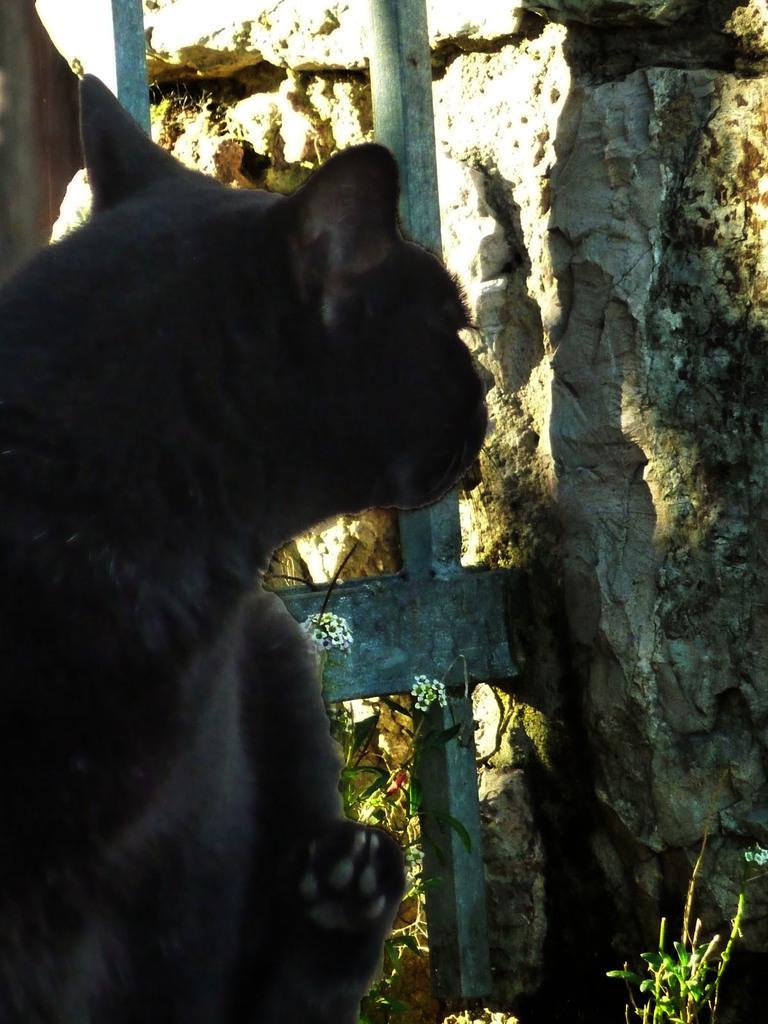Can you describe this image briefly? In this image there is an animal and behind the animal there is a ladder, rock and some plants. 